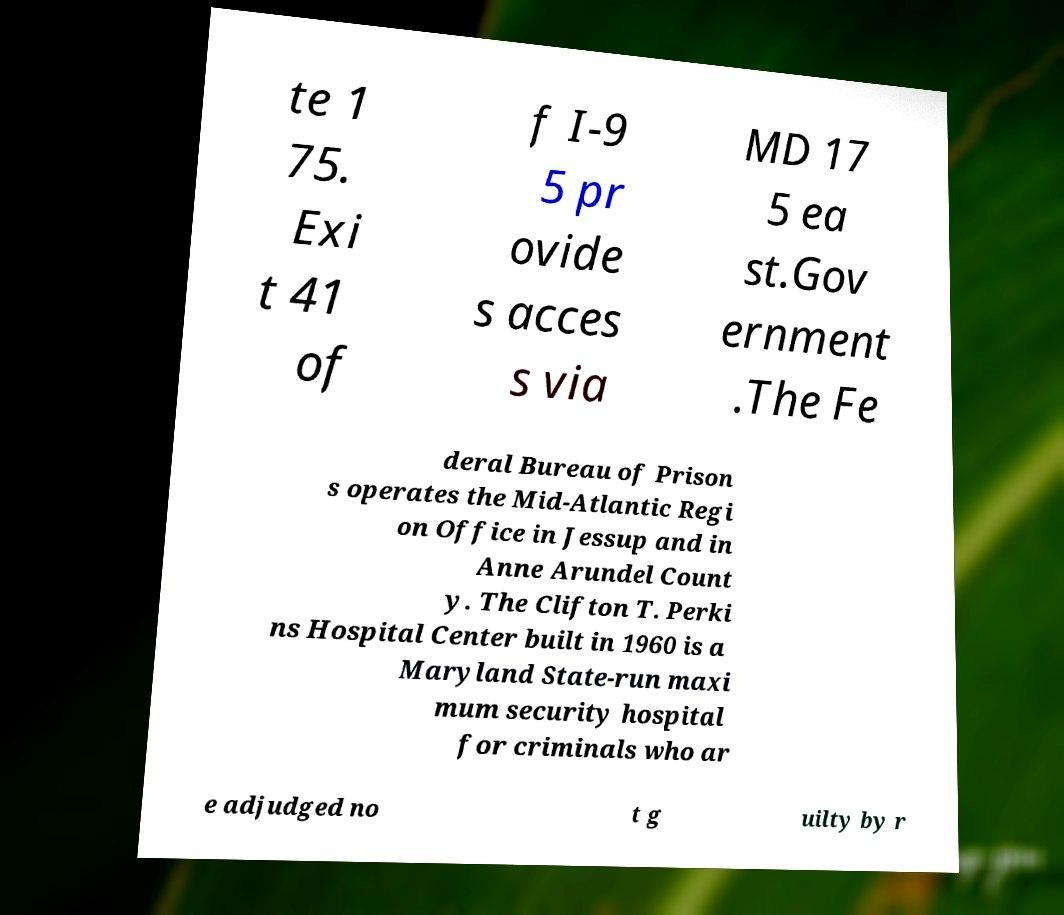There's text embedded in this image that I need extracted. Can you transcribe it verbatim? te 1 75. Exi t 41 of f I-9 5 pr ovide s acces s via MD 17 5 ea st.Gov ernment .The Fe deral Bureau of Prison s operates the Mid-Atlantic Regi on Office in Jessup and in Anne Arundel Count y. The Clifton T. Perki ns Hospital Center built in 1960 is a Maryland State-run maxi mum security hospital for criminals who ar e adjudged no t g uilty by r 